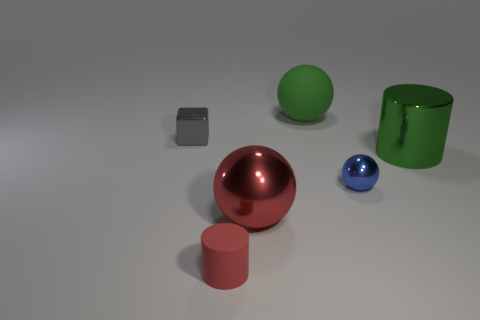How does the lighting in the image affect the appearance of the objects? The lighting in the image casts soft shadows and enhances the reflective qualities of the objects, creating a depth that highlights their shapes and contours. It makes the scene appear more three-dimensional and visually engaging.  Can you describe the shadows created by the objects? The shadows are soft and diffused, lacking harsh edges. They gently outline the base of the objects, contributing to the overall composition by adding a sense of weight and grounding for each item on the plane. 